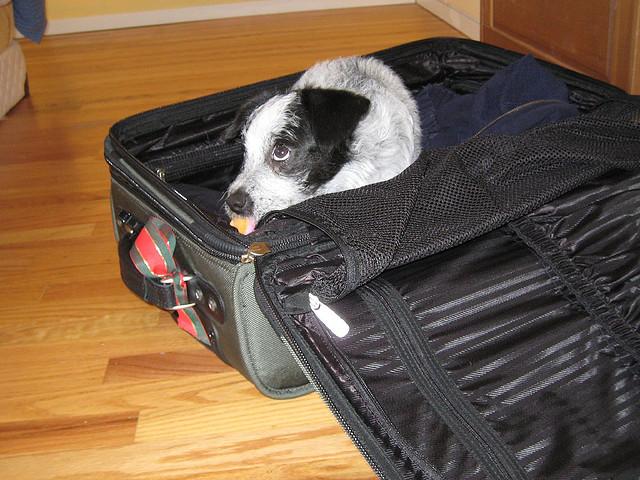What is the dog lying in?
Answer briefly. Suitcase. What color is the suitcase?
Short answer required. Black. Is the dog sleeping?
Write a very short answer. No. 